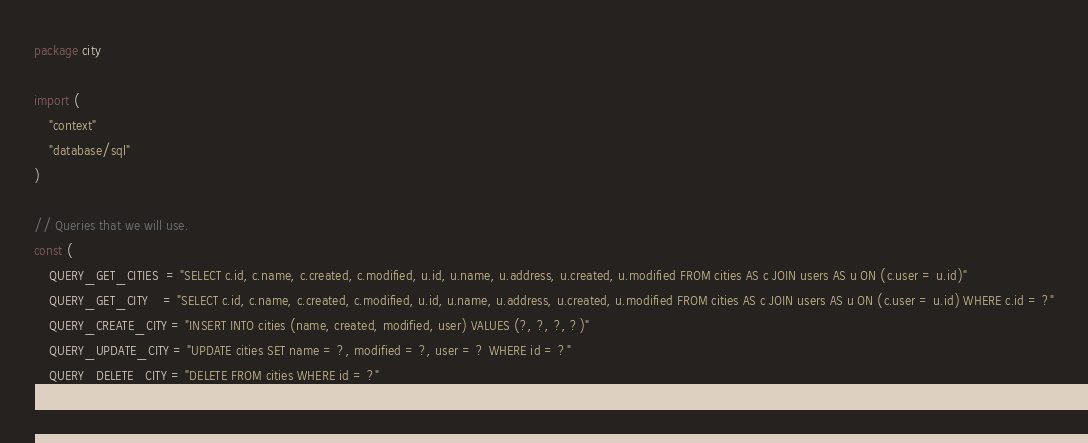<code> <loc_0><loc_0><loc_500><loc_500><_Go_>package city

import (
	"context"
	"database/sql"
)

// Queries that we will use.
const (
	QUERY_GET_CITIES  = "SELECT c.id, c.name, c.created, c.modified, u.id, u.name, u.address, u.created, u.modified FROM cities AS c JOIN users AS u ON (c.user = u.id)"
	QUERY_GET_CITY    = "SELECT c.id, c.name, c.created, c.modified, u.id, u.name, u.address, u.created, u.modified FROM cities AS c JOIN users AS u ON (c.user = u.id) WHERE c.id = ?"
	QUERY_CREATE_CITY = "INSERT INTO cities (name, created, modified, user) VALUES (?, ?, ?, ?)"
	QUERY_UPDATE_CITY = "UPDATE cities SET name = ?, modified = ?, user = ? WHERE id = ?"
	QUERY_DELETE_CITY = "DELETE FROM cities WHERE id = ?"
)
</code> 